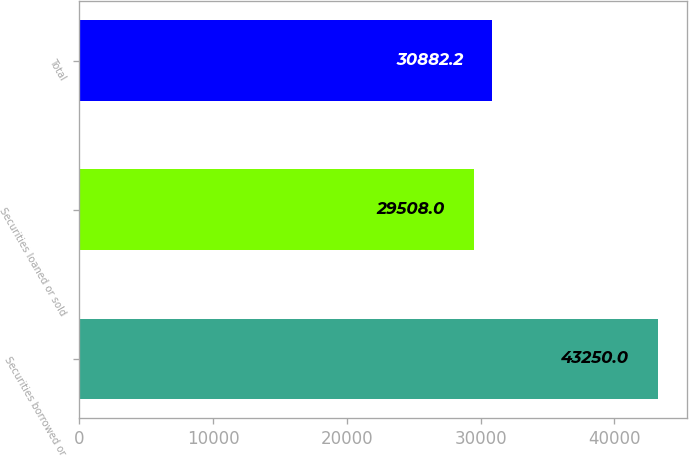Convert chart to OTSL. <chart><loc_0><loc_0><loc_500><loc_500><bar_chart><fcel>Securities borrowed or<fcel>Securities loaned or sold<fcel>Total<nl><fcel>43250<fcel>29508<fcel>30882.2<nl></chart> 